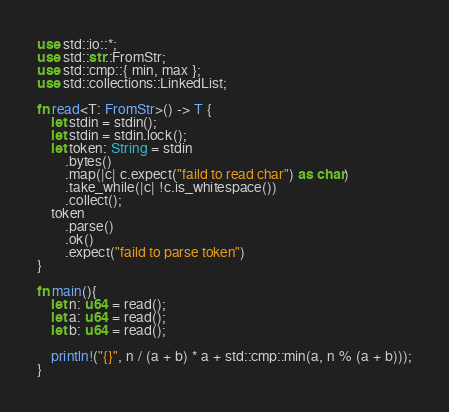<code> <loc_0><loc_0><loc_500><loc_500><_Rust_>use std::io::*;
use std::str::FromStr;
use std::cmp::{ min, max };
use std::collections::LinkedList;

fn read<T: FromStr>() -> T {
    let stdin = stdin();
    let stdin = stdin.lock();
    let token: String = stdin
        .bytes()
        .map(|c| c.expect("faild to read char") as char)
        .take_while(|c| !c.is_whitespace())
        .collect();
    token
        .parse()
        .ok()
        .expect("faild to parse token")
}

fn main(){
    let n: u64 = read();
    let a: u64 = read();
    let b: u64 = read();

    println!("{}", n / (a + b) * a + std::cmp::min(a, n % (a + b)));
}
</code> 